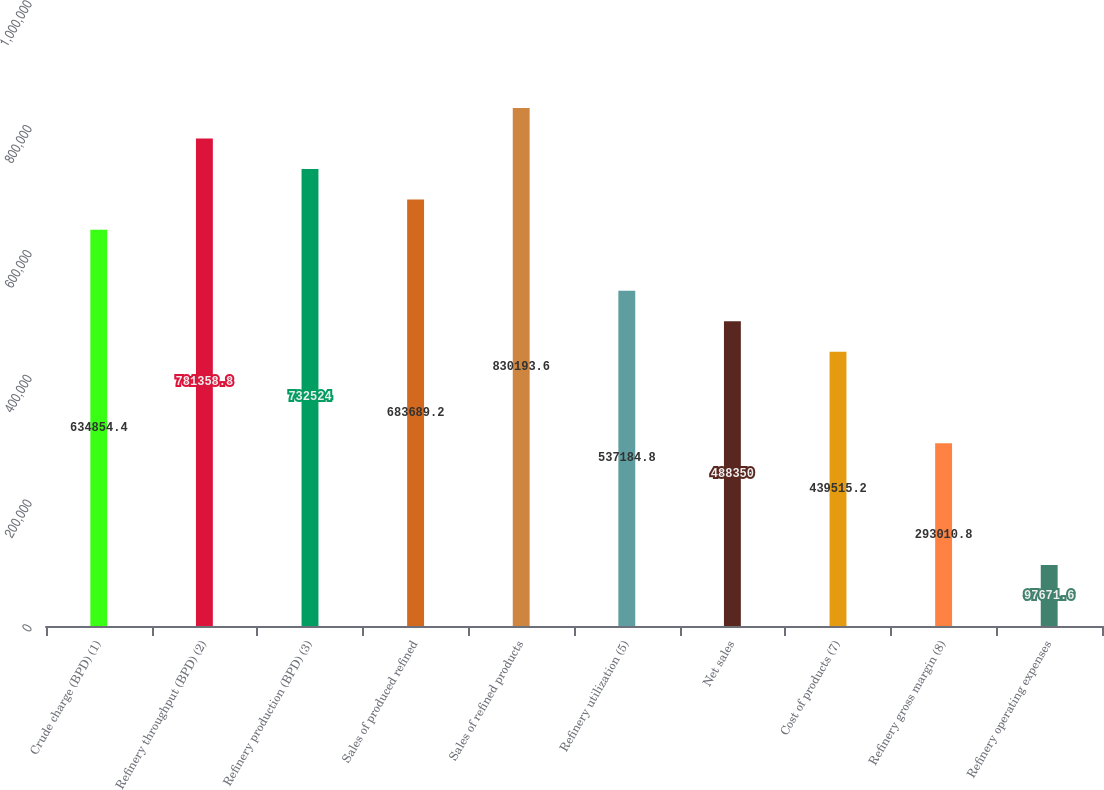<chart> <loc_0><loc_0><loc_500><loc_500><bar_chart><fcel>Crude charge (BPD) (1)<fcel>Refinery throughput (BPD) (2)<fcel>Refinery production (BPD) (3)<fcel>Sales of produced refined<fcel>Sales of refined products<fcel>Refinery utilization (5)<fcel>Net sales<fcel>Cost of products (7)<fcel>Refinery gross margin (8)<fcel>Refinery operating expenses<nl><fcel>634854<fcel>781359<fcel>732524<fcel>683689<fcel>830194<fcel>537185<fcel>488350<fcel>439515<fcel>293011<fcel>97671.6<nl></chart> 